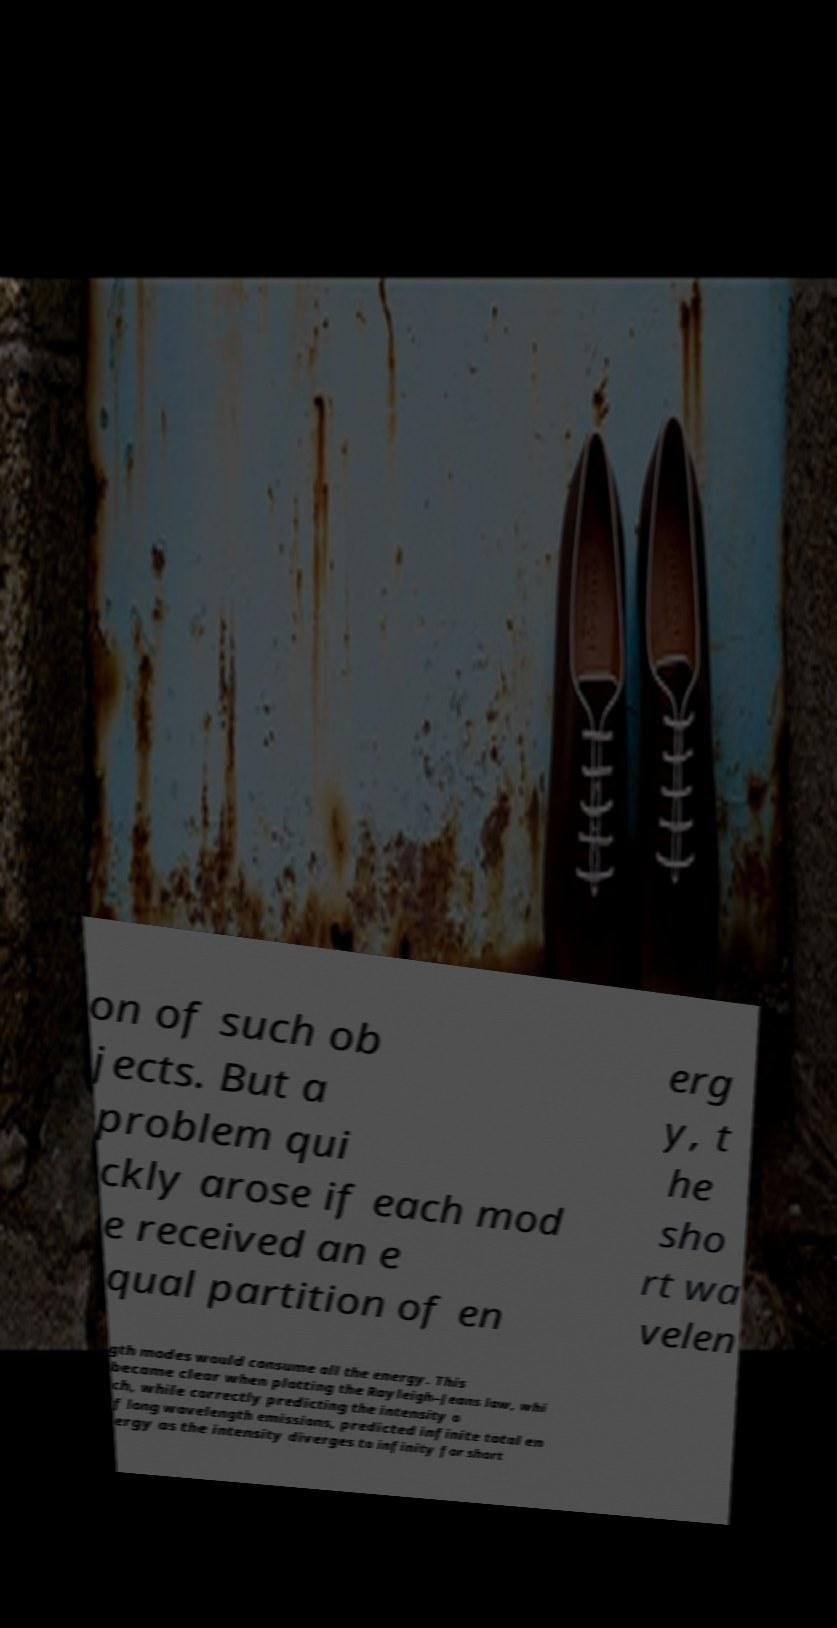Please read and relay the text visible in this image. What does it say? on of such ob jects. But a problem qui ckly arose if each mod e received an e qual partition of en erg y, t he sho rt wa velen gth modes would consume all the energy. This became clear when plotting the Rayleigh–Jeans law, whi ch, while correctly predicting the intensity o f long wavelength emissions, predicted infinite total en ergy as the intensity diverges to infinity for short 